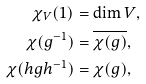<formula> <loc_0><loc_0><loc_500><loc_500>\chi _ { V } ( 1 ) & = \dim V , \\ \chi ( g ^ { - 1 } ) & = \overline { \chi ( g ) } , \\ \chi ( h g h ^ { - 1 } ) & = \chi ( g ) ,</formula> 